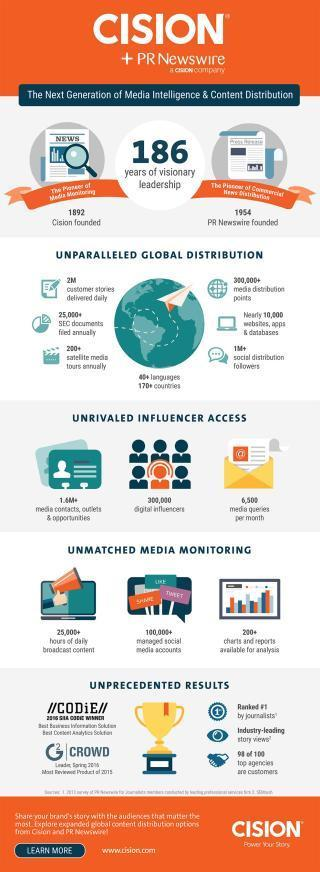How many hours of daily broadcasts contents were available for the Cision PR Newswire Company?
Answer the question with a short phrase. 25,000+ When was PR Newswire founded? 1954 How many charts & reports were available for analysis for unmatched media monitoring by the Cision PR Newswire Company? 200+ What is the number of social media accounts managed by the Cision PR Newswire Company globally? 100,000+ How many social distribution followers are there for the Cision PR Newswire Company globally? 1M+ 